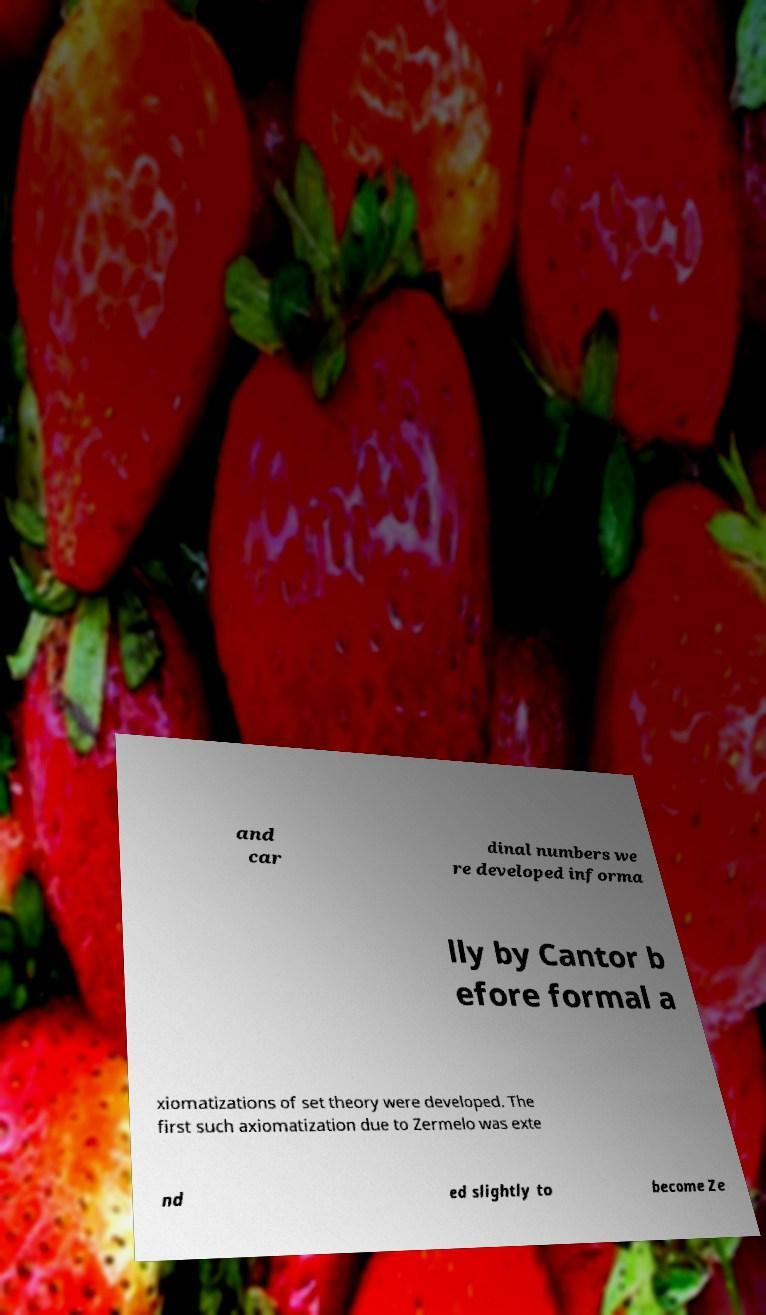Can you read and provide the text displayed in the image?This photo seems to have some interesting text. Can you extract and type it out for me? and car dinal numbers we re developed informa lly by Cantor b efore formal a xiomatizations of set theory were developed. The first such axiomatization due to Zermelo was exte nd ed slightly to become Ze 